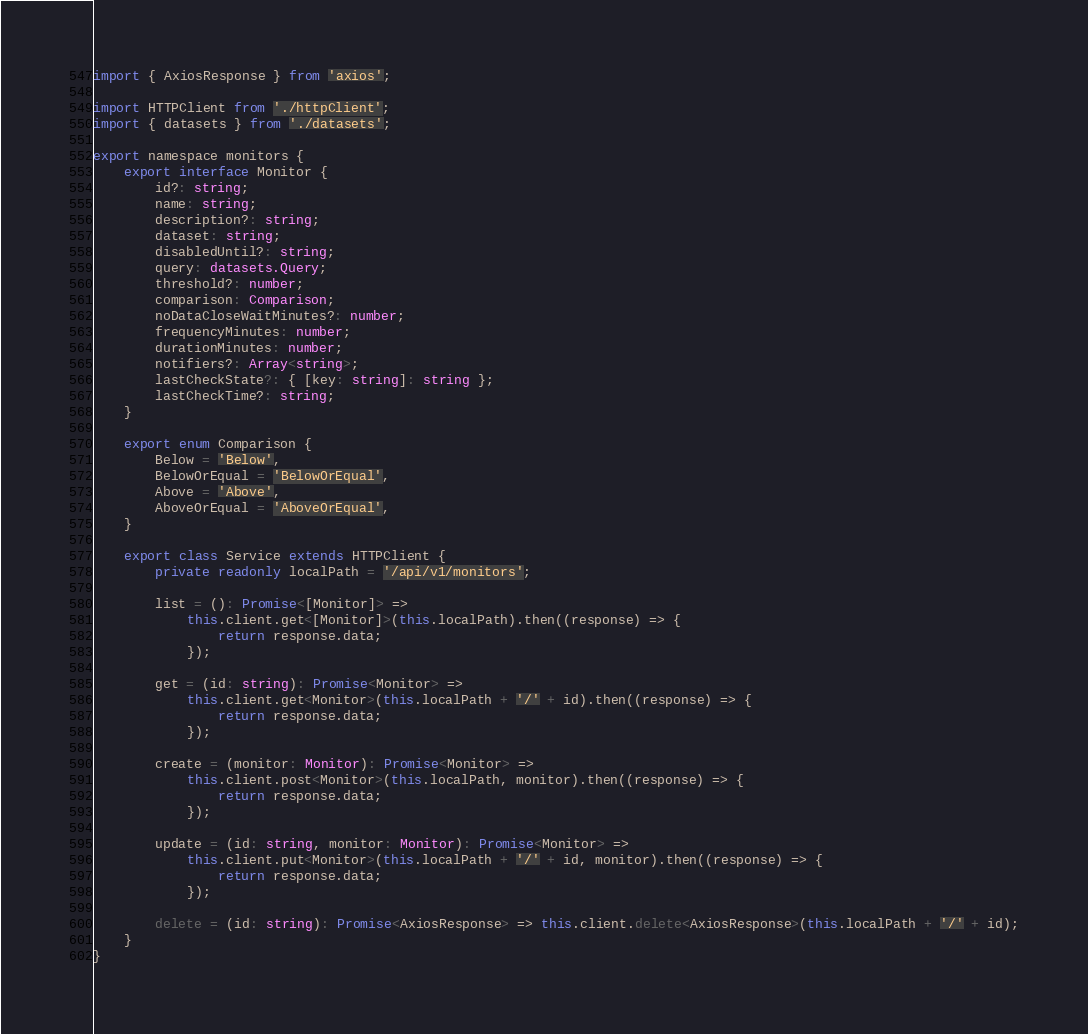<code> <loc_0><loc_0><loc_500><loc_500><_TypeScript_>import { AxiosResponse } from 'axios';

import HTTPClient from './httpClient';
import { datasets } from './datasets';

export namespace monitors {
    export interface Monitor {
        id?: string;
        name: string;
        description?: string;
        dataset: string;
        disabledUntil?: string;
        query: datasets.Query;
        threshold?: number;
        comparison: Comparison;
        noDataCloseWaitMinutes?: number;
        frequencyMinutes: number;
        durationMinutes: number;
        notifiers?: Array<string>;
        lastCheckState?: { [key: string]: string };
        lastCheckTime?: string;
    }

    export enum Comparison {
        Below = 'Below',
        BelowOrEqual = 'BelowOrEqual',
        Above = 'Above',
        AboveOrEqual = 'AboveOrEqual',
    }

    export class Service extends HTTPClient {
        private readonly localPath = '/api/v1/monitors';

        list = (): Promise<[Monitor]> =>
            this.client.get<[Monitor]>(this.localPath).then((response) => {
                return response.data;
            });

        get = (id: string): Promise<Monitor> =>
            this.client.get<Monitor>(this.localPath + '/' + id).then((response) => {
                return response.data;
            });

        create = (monitor: Monitor): Promise<Monitor> =>
            this.client.post<Monitor>(this.localPath, monitor).then((response) => {
                return response.data;
            });

        update = (id: string, monitor: Monitor): Promise<Monitor> =>
            this.client.put<Monitor>(this.localPath + '/' + id, monitor).then((response) => {
                return response.data;
            });

        delete = (id: string): Promise<AxiosResponse> => this.client.delete<AxiosResponse>(this.localPath + '/' + id);
    }
}</code> 